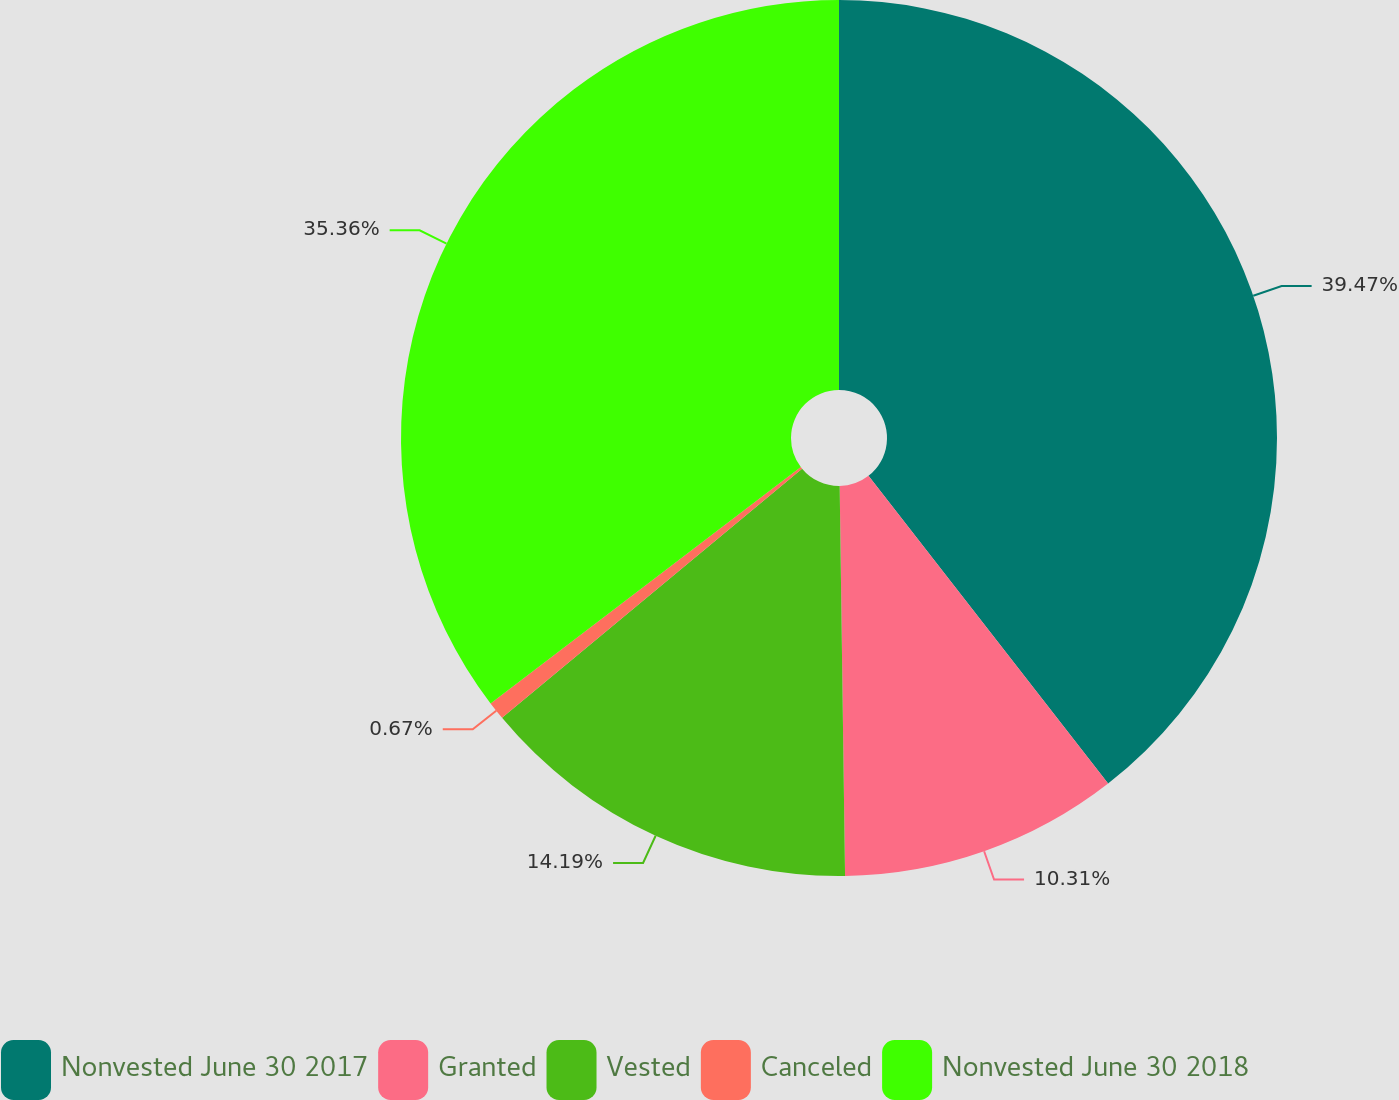<chart> <loc_0><loc_0><loc_500><loc_500><pie_chart><fcel>Nonvested June 30 2017<fcel>Granted<fcel>Vested<fcel>Canceled<fcel>Nonvested June 30 2018<nl><fcel>39.47%<fcel>10.31%<fcel>14.19%<fcel>0.67%<fcel>35.36%<nl></chart> 